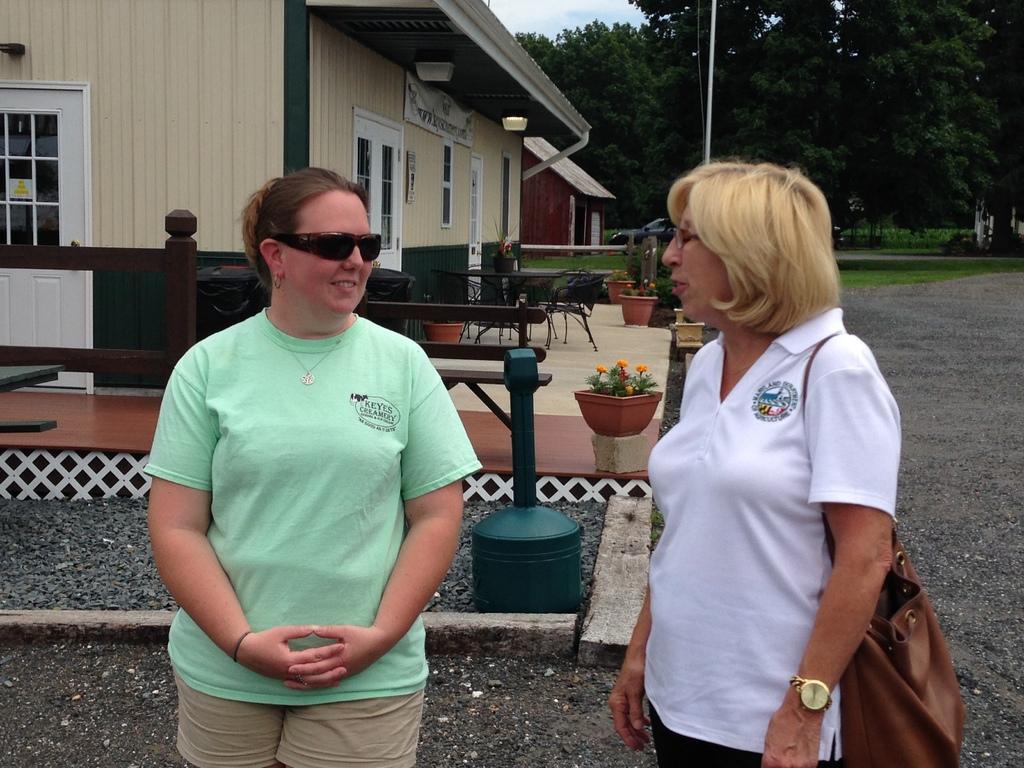In one or two sentences, can you explain what this image depicts? In this image, there are two persons standing and wearing clothes. There is a table and some chair in front of the house. There is a flowers pot in the middle of the image. There are some trees in the top right of the image. 